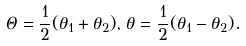<formula> <loc_0><loc_0><loc_500><loc_500>\Theta = \frac { 1 } { 2 } ( \theta _ { 1 } + \theta _ { 2 } ) , \, \theta = \frac { 1 } { 2 } ( \theta _ { 1 } - \theta _ { 2 } ) .</formula> 